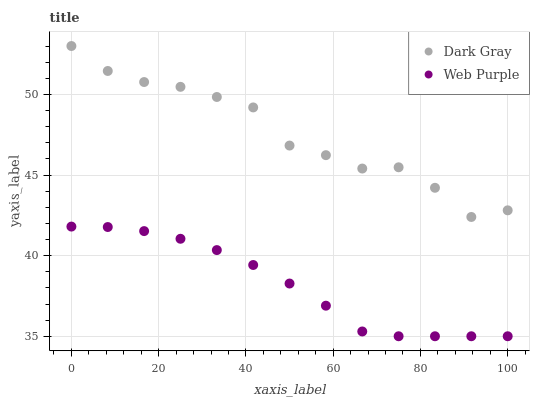Does Web Purple have the minimum area under the curve?
Answer yes or no. Yes. Does Dark Gray have the maximum area under the curve?
Answer yes or no. Yes. Does Web Purple have the maximum area under the curve?
Answer yes or no. No. Is Web Purple the smoothest?
Answer yes or no. Yes. Is Dark Gray the roughest?
Answer yes or no. Yes. Is Web Purple the roughest?
Answer yes or no. No. Does Web Purple have the lowest value?
Answer yes or no. Yes. Does Dark Gray have the highest value?
Answer yes or no. Yes. Does Web Purple have the highest value?
Answer yes or no. No. Is Web Purple less than Dark Gray?
Answer yes or no. Yes. Is Dark Gray greater than Web Purple?
Answer yes or no. Yes. Does Web Purple intersect Dark Gray?
Answer yes or no. No. 